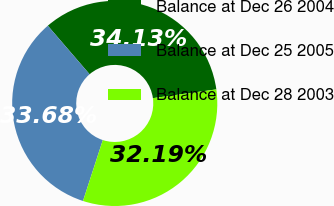Convert chart. <chart><loc_0><loc_0><loc_500><loc_500><pie_chart><fcel>Balance at Dec 26 2004<fcel>Balance at Dec 25 2005<fcel>Balance at Dec 28 2003<nl><fcel>34.13%<fcel>33.68%<fcel>32.19%<nl></chart> 